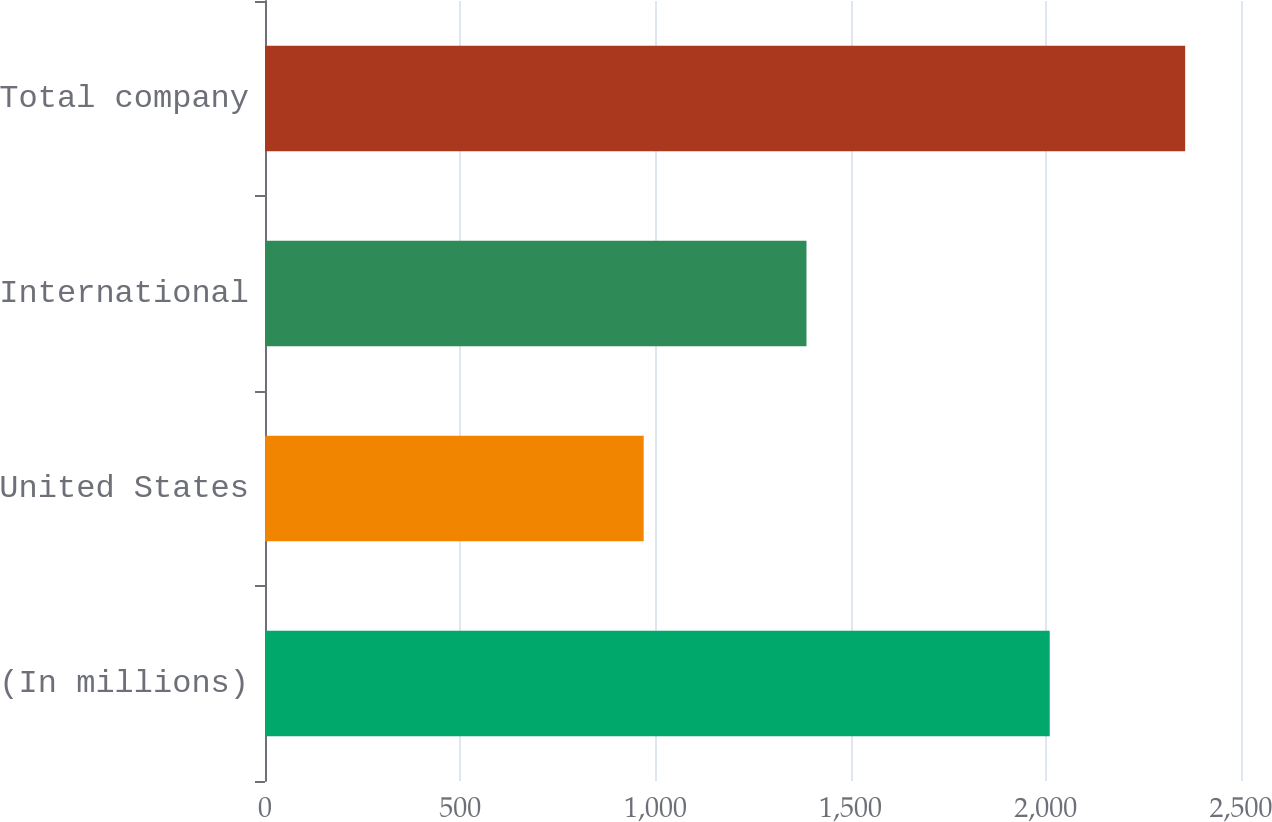Convert chart. <chart><loc_0><loc_0><loc_500><loc_500><bar_chart><fcel>(In millions)<fcel>United States<fcel>International<fcel>Total company<nl><fcel>2010<fcel>970<fcel>1387<fcel>2357<nl></chart> 